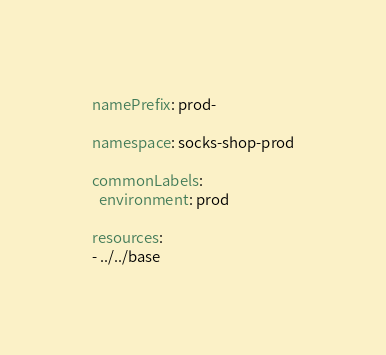Convert code to text. <code><loc_0><loc_0><loc_500><loc_500><_YAML_>namePrefix: prod-

namespace: socks-shop-prod

commonLabels:
  environment: prod

resources:
- ../../base
</code> 